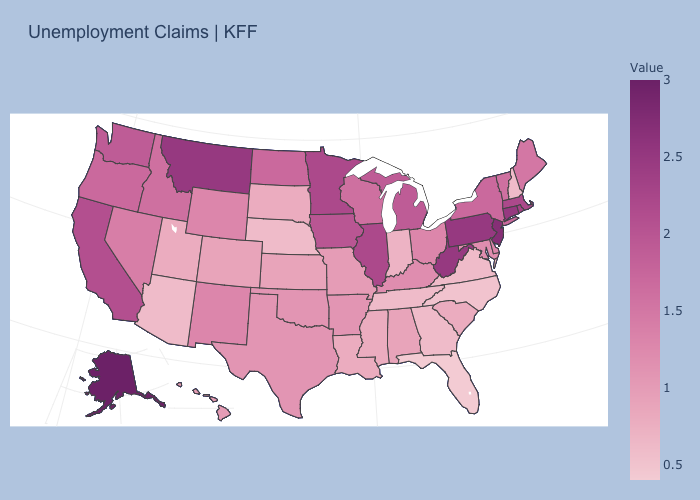Does Louisiana have the lowest value in the USA?
Quick response, please. No. Does Florida have the lowest value in the USA?
Give a very brief answer. Yes. Does New Jersey have the highest value in the Northeast?
Short answer required. Yes. Does Michigan have the lowest value in the USA?
Keep it brief. No. 